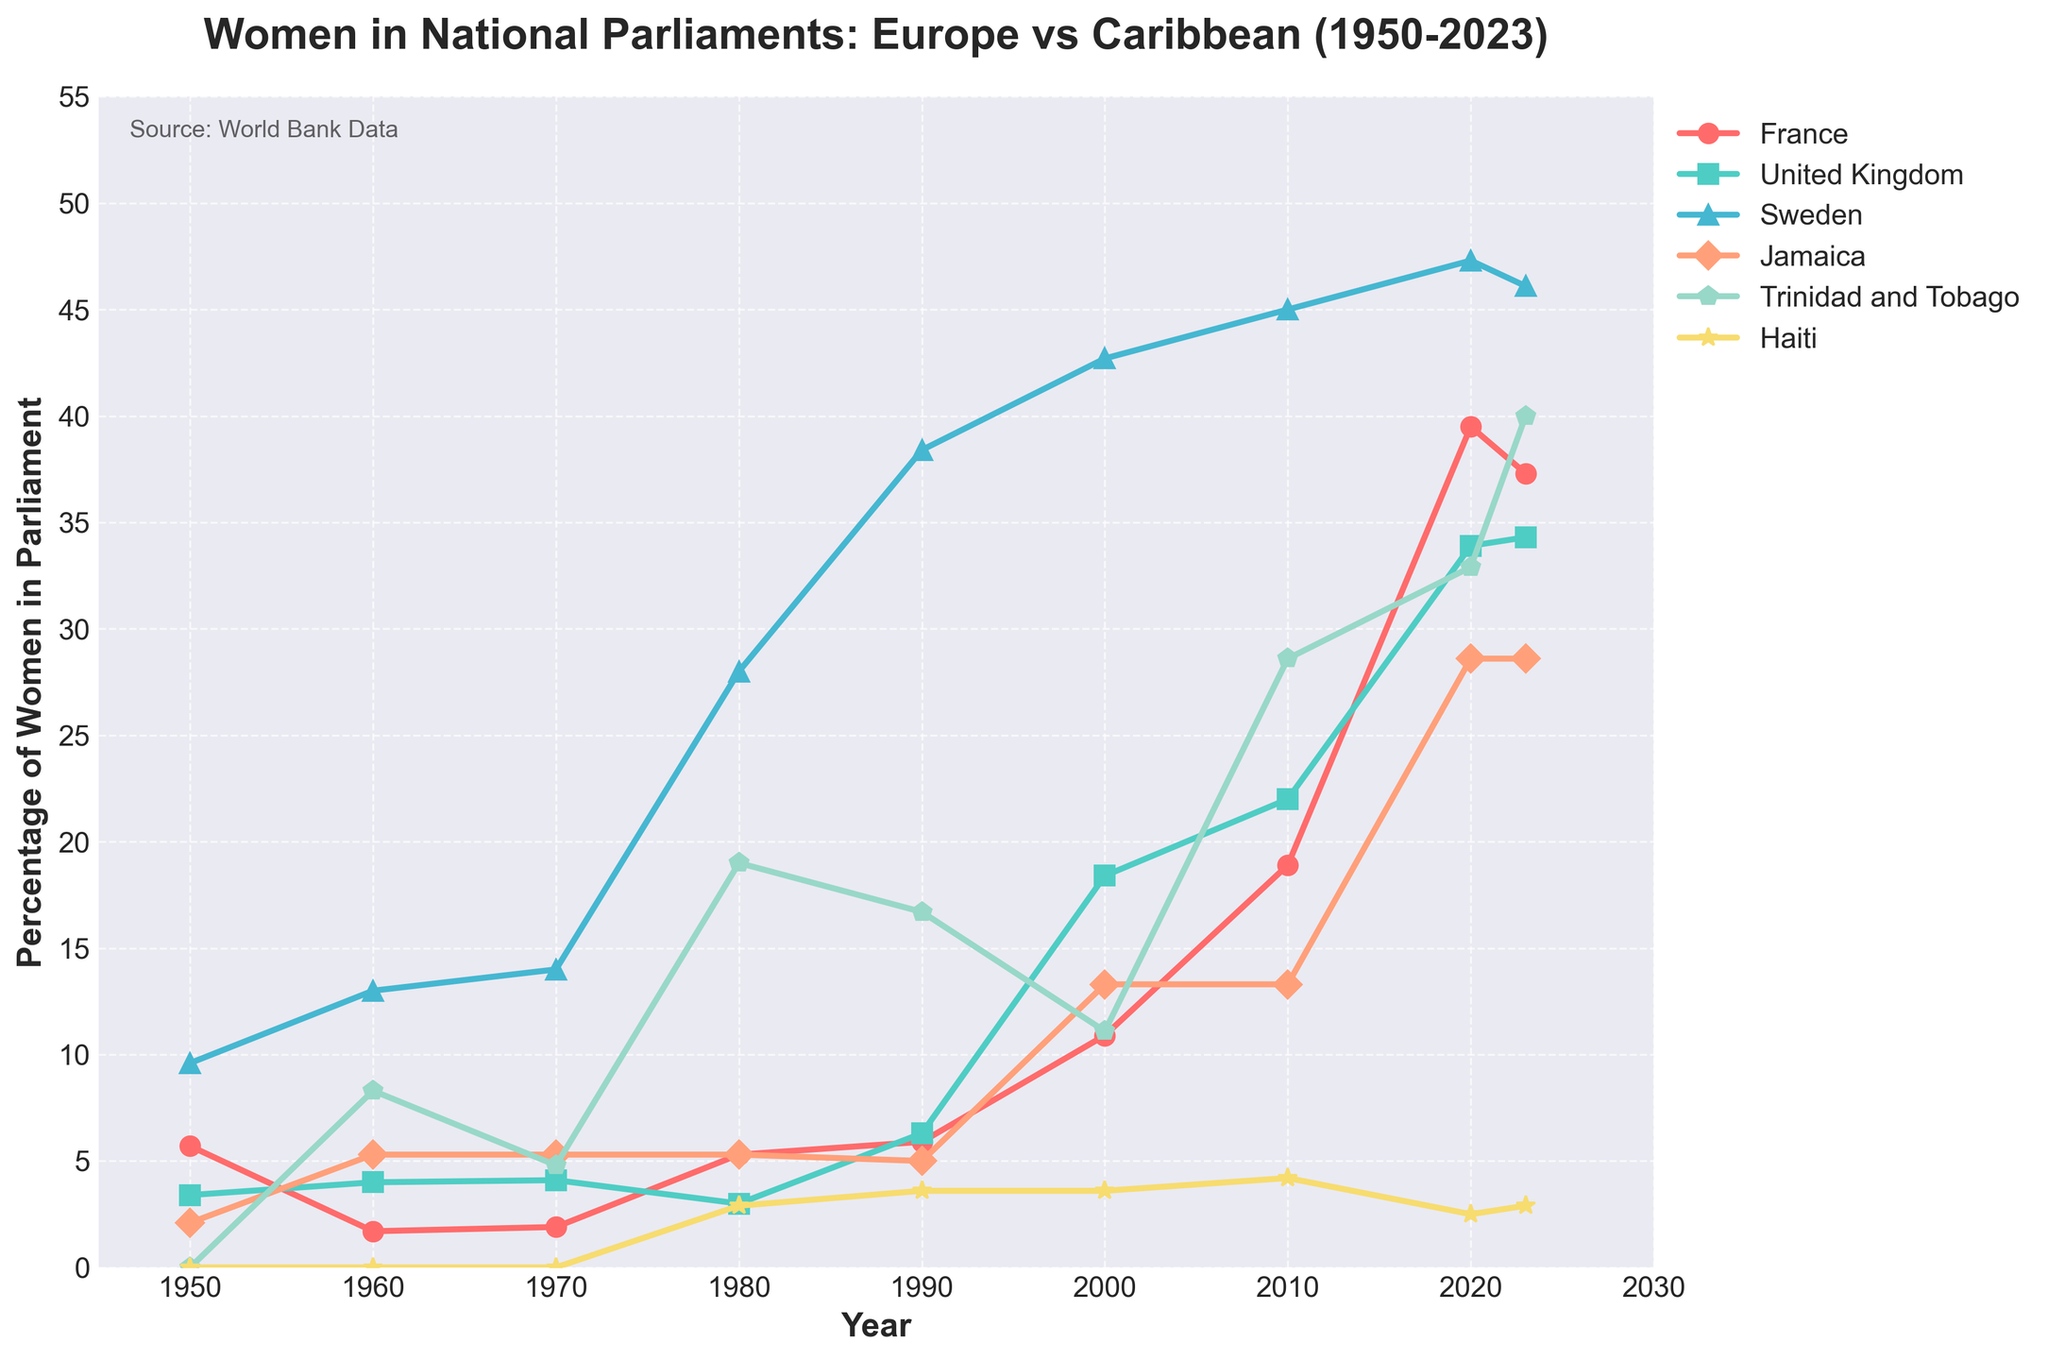What is the percentage of women in parliament in Sweden in 2023? Locate the data point for Sweden on the chart in 2023.
Answer: 46.1 Which country had the highest percentage of women in parliament in 1980? Compare the values for each country in 1980. Sweden had the highest at 28%.
Answer: Sweden Between 1980 and 2023, which country saw the greatest increase in the percentage of women in parliament? Calculate the percentage increase for each country from 1980 to 2023 and identify the greatest. France increased from 5.3% to 37.3%, which is an increase of 32%.
Answer: France Did any country have a decrease in the percentage of women in parliament between 2020 and 2023? Compare the percentages in 2020 and 2023 for each country. France decreased from 39.5% to 37.3%, and Haiti decreased from 2.5% to 2.9%. No country shows a decrease.
Answer: None What is the difference in the percentage of women in parliament between the United Kingdom and Trinidad and Tobago in 2020? Subtract the percentage of women in the UK from that in Trinidad and Tobago for 2020. 32.9% - 33.9% = -1%
Answer: 1% Which country had a relatively stable percentage of women in parliament from 1950 to 1990? Observe the countries' data trends between 1950 and 1990. Jamaica's percentage fluctuated slightly but remained around 5%.
Answer: Jamaica What year did Sweden surpass 40% of women representation in its parliament? Identify the first year Sweden's value exceeded 40%. This occurred in 2000 when the value was 42.7%.
Answer: 2000 In 2023, what is the difference in the percentage of women in parliament between France and Haiti? Subtract Haiti's percentage from France's in 2023. 37.3% - 2.9% = 34.4%.
Answer: 34.4% Which Caribbean country had the highest increase in the percentage of women in parliament between 2000 and 2010? Compare the percentage increase for each Caribbean country between 2000 and 2010. Trinidad and Tobago increased from 11.1% to 28.6%.
Answer: Trinidad and Tobago What is the trend in the percentage of women in parliament in Haiti from 1980 to 2023? Observe the data points for Haiti from 1980 to 2023 to determine the trend. Haiti slightly increased from 2.9% to 3.6% between 1980 and 2000, to 4.2% in 2010, but decreased to 2.5% in 2020 and increased to 2.9% in 2023.
Answer: Slight fluctuating increase 